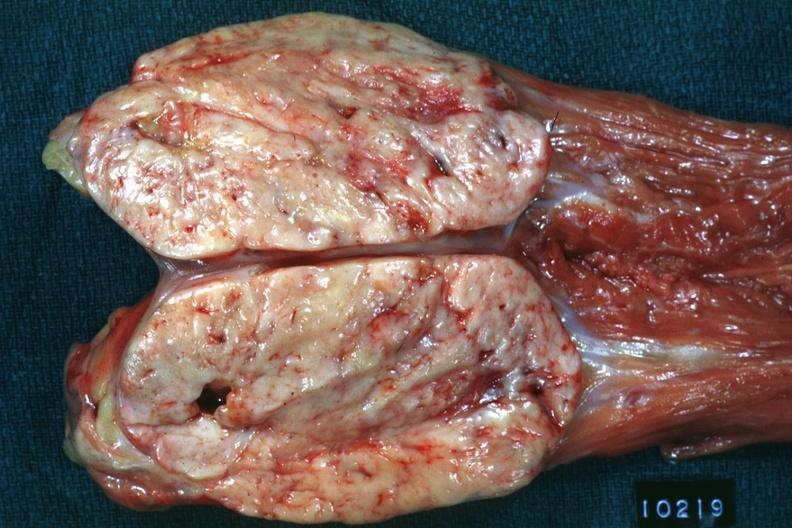how does opened muscle psoa natural color large ovoid sarcoma?
Answer the question using a single word or phrase. Typical 